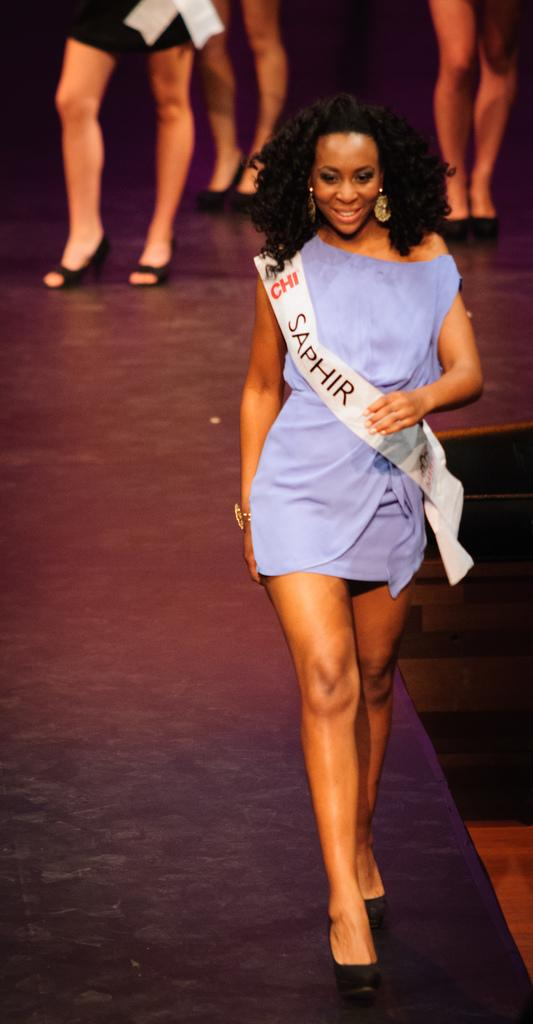<image>
Summarize the visual content of the image. A beauty pageant winner from Saphir is walking down the runway. 